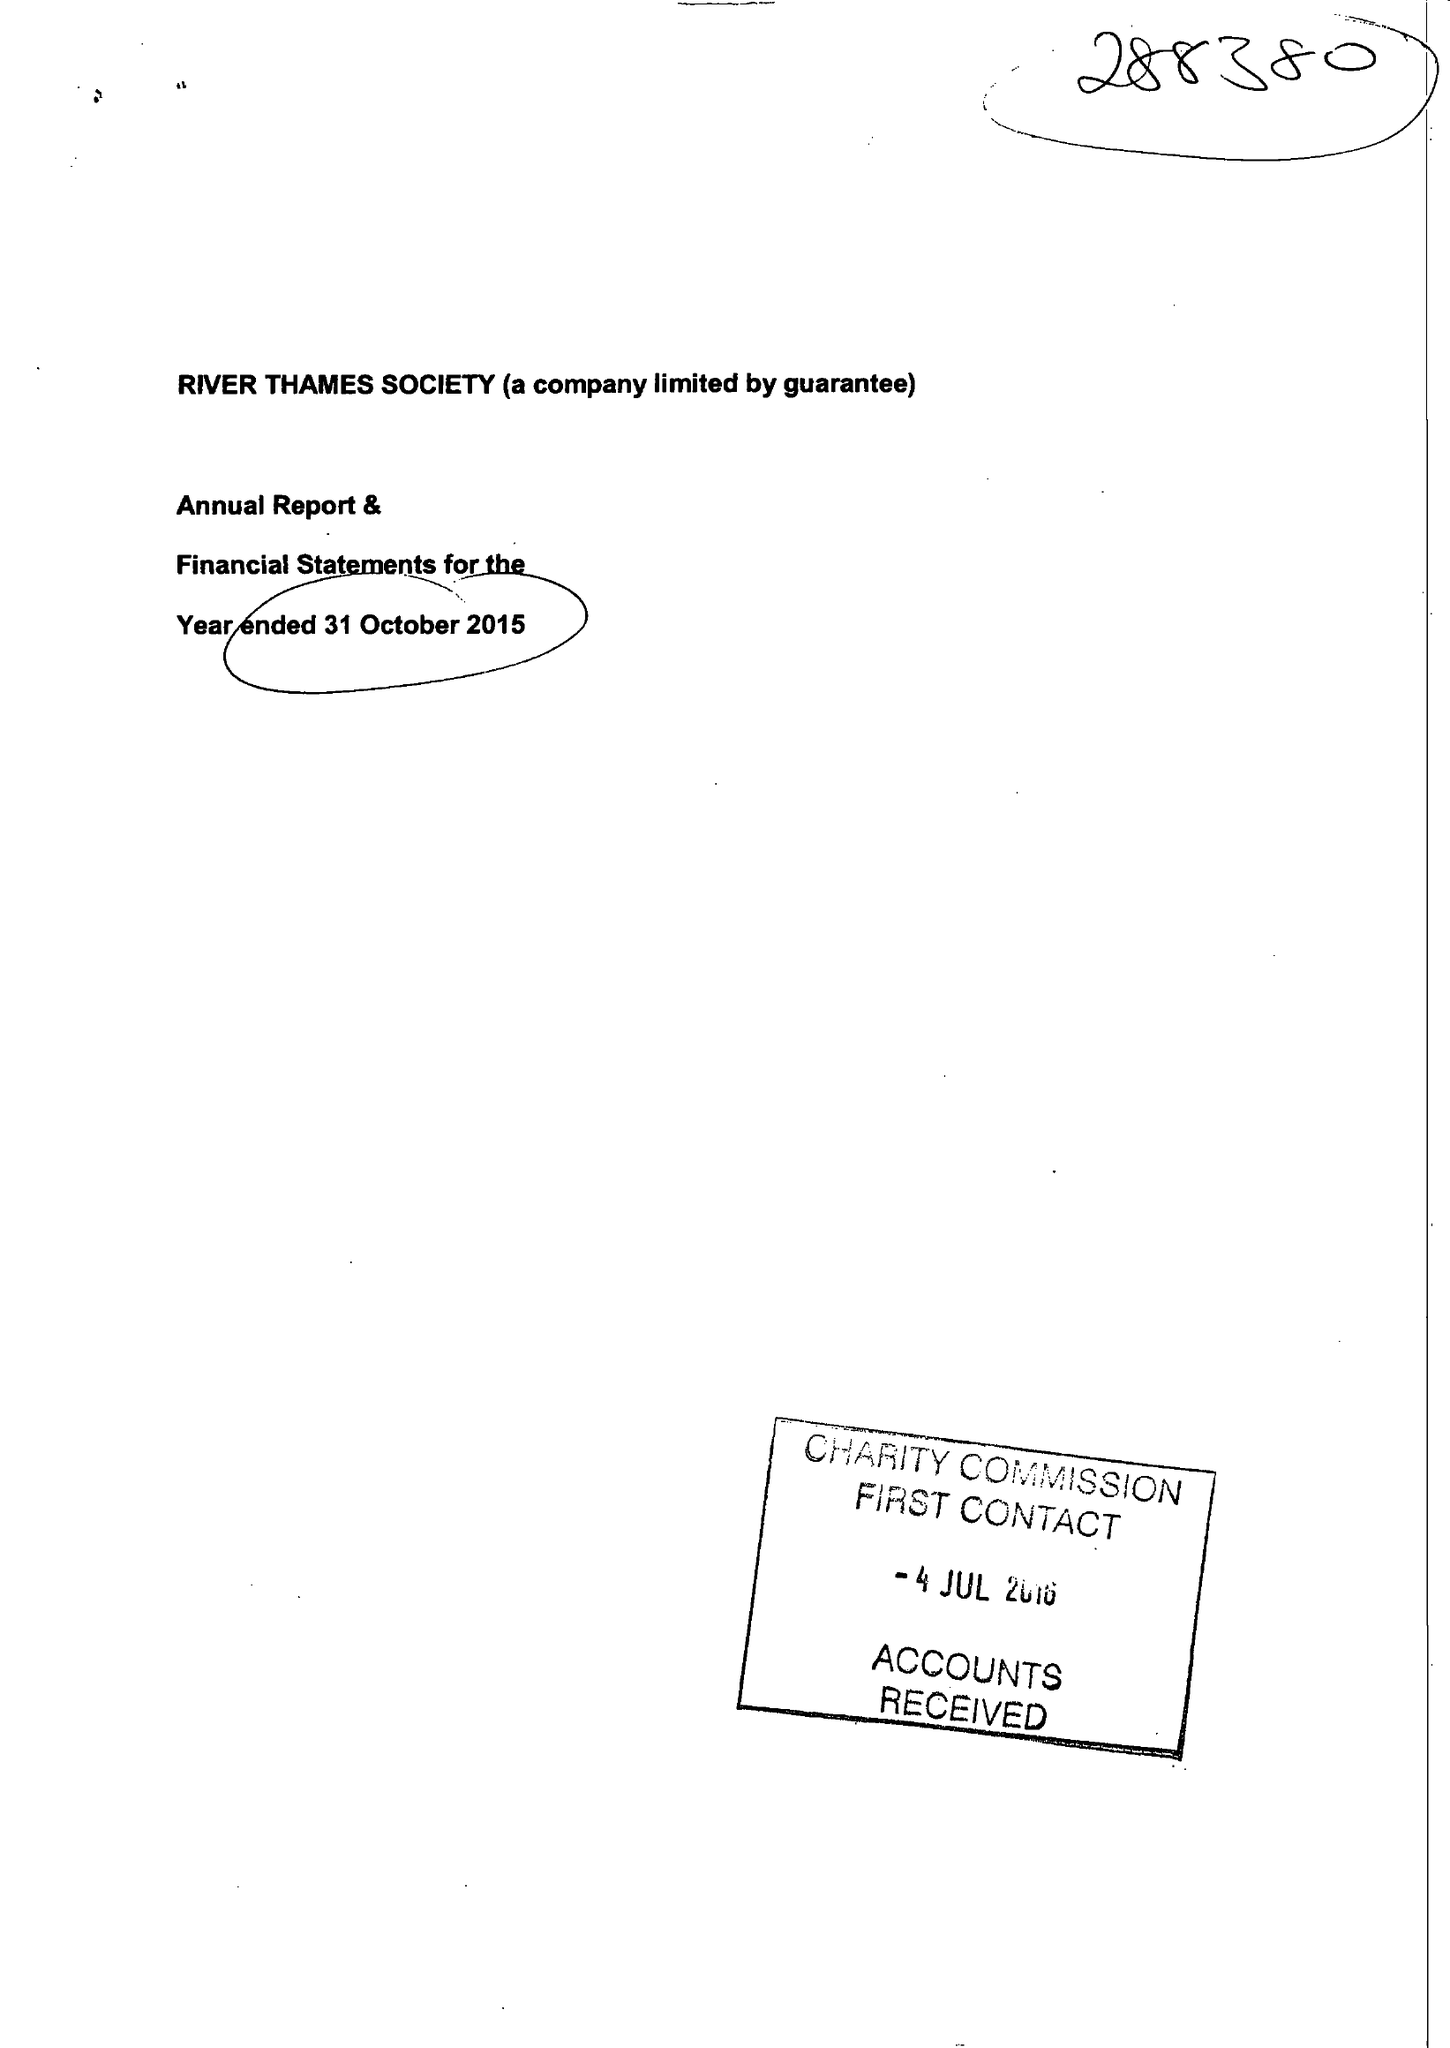What is the value for the address__street_line?
Answer the question using a single word or phrase. 28 BEAUMONT ROAD 